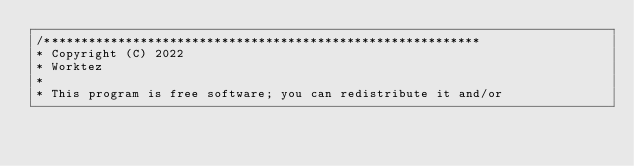<code> <loc_0><loc_0><loc_500><loc_500><_TypeScript_>/*********************************************************** 
* Copyright (C) 2022 
* Worktez 
* 
* This program is free software; you can redistribute it and/or </code> 